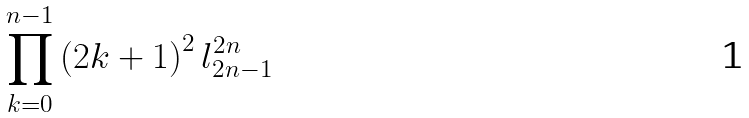Convert formula to latex. <formula><loc_0><loc_0><loc_500><loc_500>\prod _ { k = 0 } ^ { n - 1 } \left ( 2 k + 1 \right ) ^ { 2 } l _ { 2 n - 1 } ^ { 2 n }</formula> 